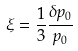<formula> <loc_0><loc_0><loc_500><loc_500>\xi = \frac { 1 } { 3 } \frac { \delta p _ { 0 } } { p _ { 0 } }</formula> 